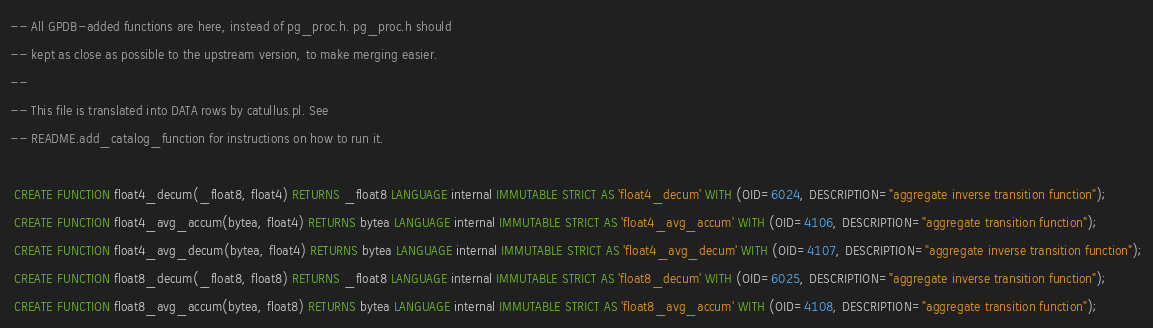<code> <loc_0><loc_0><loc_500><loc_500><_SQL_>-- All GPDB-added functions are here, instead of pg_proc.h. pg_proc.h should
-- kept as close as possible to the upstream version, to make merging easier.
--
-- This file is translated into DATA rows by catullus.pl. See
-- README.add_catalog_function for instructions on how to run it.

 CREATE FUNCTION float4_decum(_float8, float4) RETURNS _float8 LANGUAGE internal IMMUTABLE STRICT AS 'float4_decum' WITH (OID=6024, DESCRIPTION="aggregate inverse transition function");
 CREATE FUNCTION float4_avg_accum(bytea, float4) RETURNS bytea LANGUAGE internal IMMUTABLE STRICT AS 'float4_avg_accum' WITH (OID=4106, DESCRIPTION="aggregate transition function");
 CREATE FUNCTION float4_avg_decum(bytea, float4) RETURNS bytea LANGUAGE internal IMMUTABLE STRICT AS 'float4_avg_decum' WITH (OID=4107, DESCRIPTION="aggregate inverse transition function");
 CREATE FUNCTION float8_decum(_float8, float8) RETURNS _float8 LANGUAGE internal IMMUTABLE STRICT AS 'float8_decum' WITH (OID=6025, DESCRIPTION="aggregate inverse transition function");
 CREATE FUNCTION float8_avg_accum(bytea, float8) RETURNS bytea LANGUAGE internal IMMUTABLE STRICT AS 'float8_avg_accum' WITH (OID=4108, DESCRIPTION="aggregate transition function");</code> 